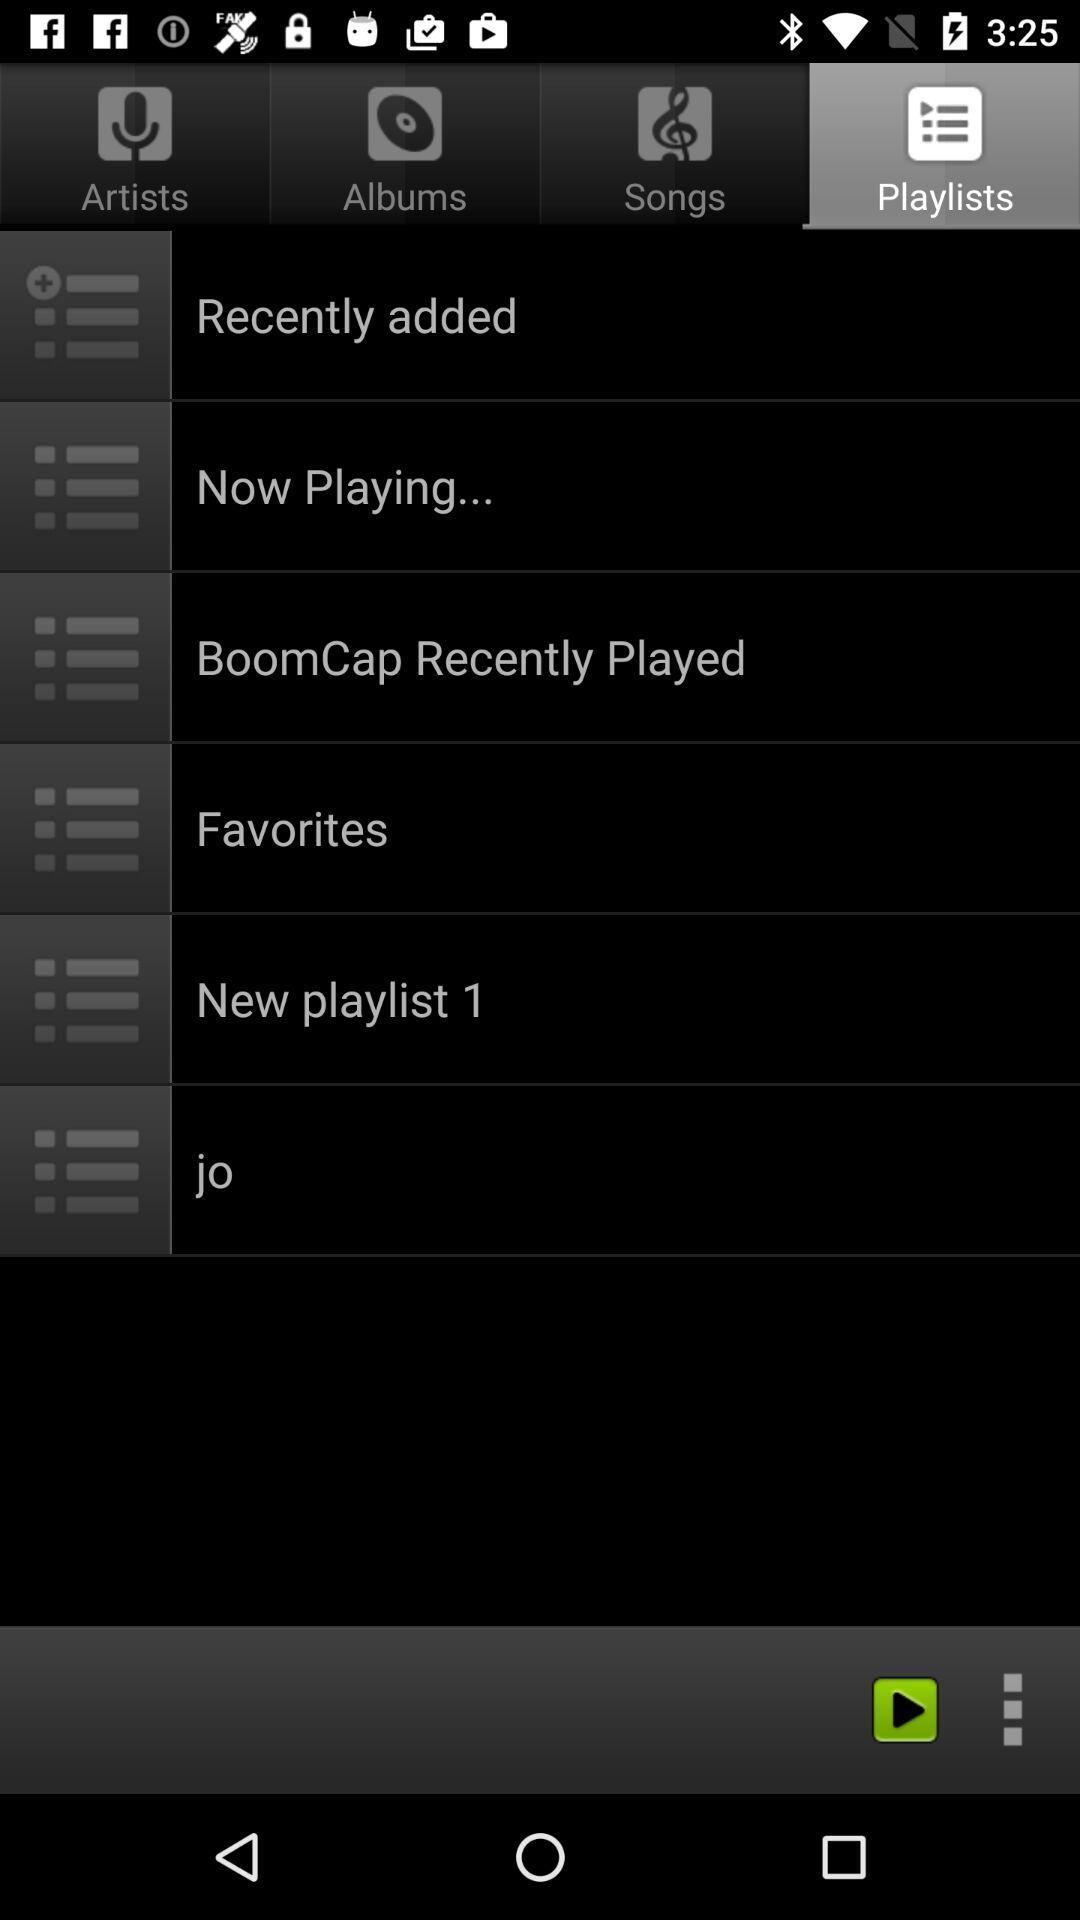Which tab is selected? The selected tab is "Playlists". 